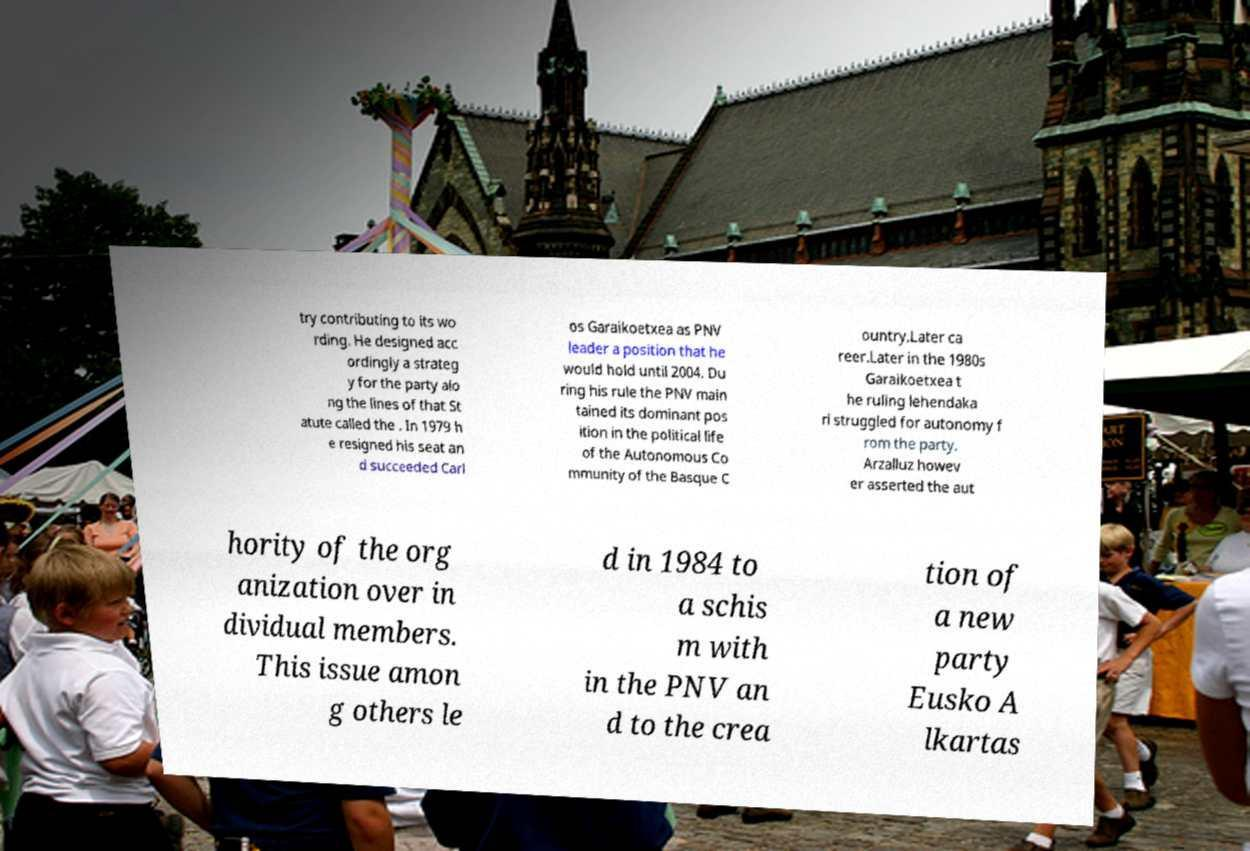I need the written content from this picture converted into text. Can you do that? try contributing to its wo rding. He designed acc ordingly a strateg y for the party alo ng the lines of that St atute called the . In 1979 h e resigned his seat an d succeeded Carl os Garaikoetxea as PNV leader a position that he would hold until 2004. Du ring his rule the PNV main tained its dominant pos ition in the political life of the Autonomous Co mmunity of the Basque C ountry.Later ca reer.Later in the 1980s Garaikoetxea t he ruling lehendaka ri struggled for autonomy f rom the party. Arzalluz howev er asserted the aut hority of the org anization over in dividual members. This issue amon g others le d in 1984 to a schis m with in the PNV an d to the crea tion of a new party Eusko A lkartas 